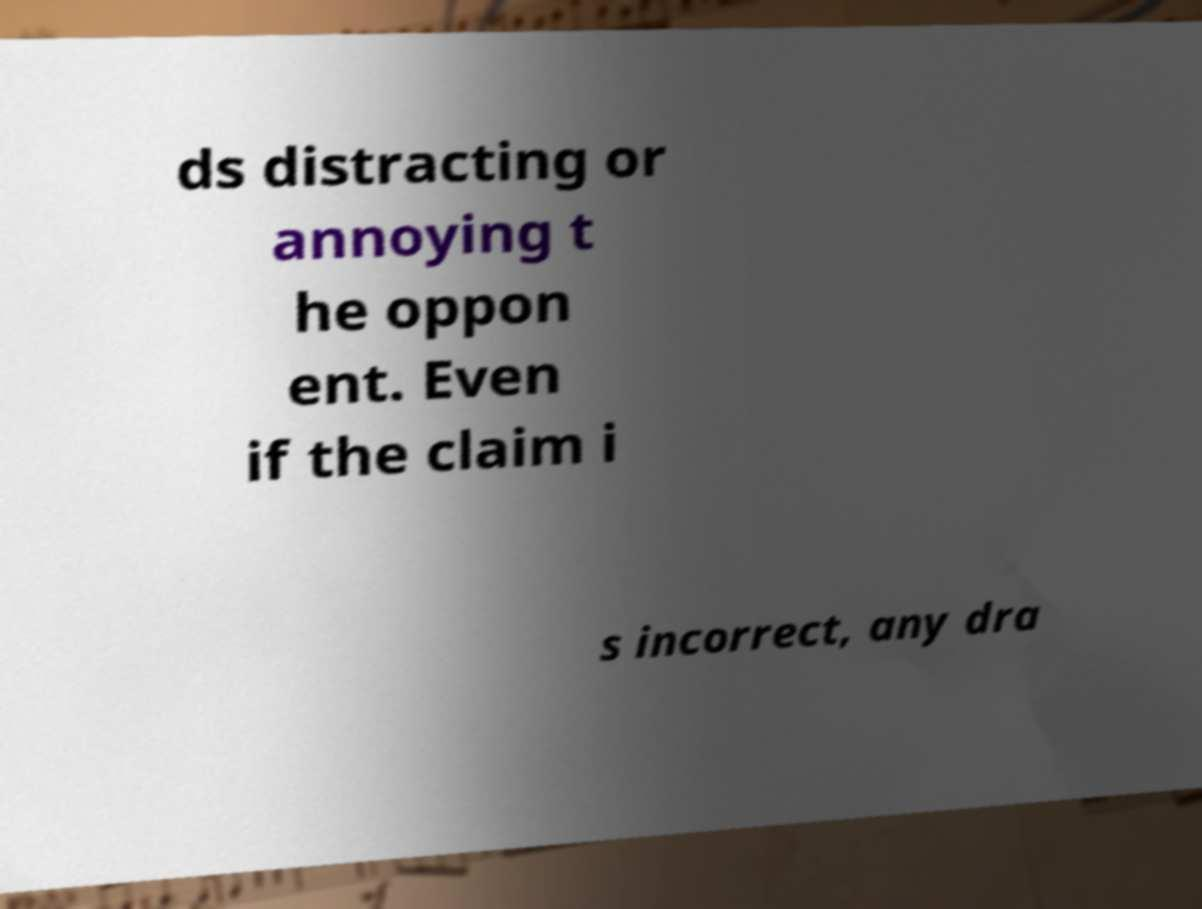What messages or text are displayed in this image? I need them in a readable, typed format. ds distracting or annoying t he oppon ent. Even if the claim i s incorrect, any dra 